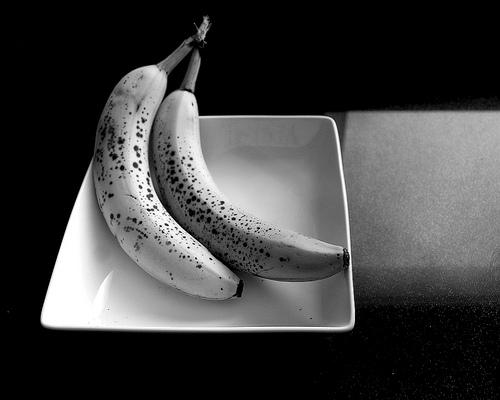Tell me about the appearance of the stems of the bananas. The stems of the bananas are frayed and connected to each other. Can you count how many bananas are on the plate? There are two bananas on the white plate. What is the main object in the image and where is it placed? Two bananas are the main object, placed on a white plate on a black counter. Describe any visible imperfections on the bananas. The bananas have black spots, a black tip, and a bruised area. Evaluate the quality of the image. The image has a high quality with detailed annotations for objects and their interactions. Provide a general sentiment about the image. The image has a neutral sentiment, showing overripe bananas on a simple white plate. Please describe the current condition of the bananas. The bananas are overripe with brown spots and bruised areas. Name an interesting feature about the white plate. The white plate has a square shape and four corners. What could be inferred about the surface near the bananas? The surface near the bananas is a black reflective table or counter with a grey area. What interaction can be observed between the objects in the image? The bananas are resting on the white plate, which is placed on the black counter. 